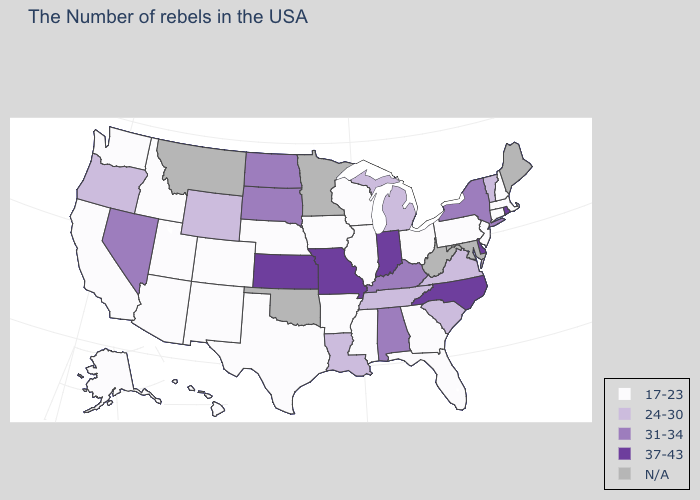What is the value of Pennsylvania?
Write a very short answer. 17-23. Which states have the highest value in the USA?
Concise answer only. Rhode Island, Delaware, North Carolina, Indiana, Missouri, Kansas. What is the value of Maryland?
Write a very short answer. N/A. Among the states that border Wisconsin , does Michigan have the lowest value?
Give a very brief answer. No. Among the states that border Iowa , which have the lowest value?
Keep it brief. Wisconsin, Illinois, Nebraska. What is the value of Louisiana?
Be succinct. 24-30. Which states have the lowest value in the Northeast?
Keep it brief. Massachusetts, New Hampshire, Connecticut, New Jersey, Pennsylvania. What is the value of Ohio?
Keep it brief. 17-23. Which states have the highest value in the USA?
Answer briefly. Rhode Island, Delaware, North Carolina, Indiana, Missouri, Kansas. Does North Carolina have the highest value in the USA?
Concise answer only. Yes. Does Kentucky have the lowest value in the USA?
Short answer required. No. Does North Carolina have the highest value in the South?
Keep it brief. Yes. What is the highest value in the MidWest ?
Keep it brief. 37-43. Name the states that have a value in the range N/A?
Give a very brief answer. Maine, Maryland, West Virginia, Minnesota, Oklahoma, Montana. Which states have the lowest value in the USA?
Give a very brief answer. Massachusetts, New Hampshire, Connecticut, New Jersey, Pennsylvania, Ohio, Florida, Georgia, Wisconsin, Illinois, Mississippi, Arkansas, Iowa, Nebraska, Texas, Colorado, New Mexico, Utah, Arizona, Idaho, California, Washington, Alaska, Hawaii. 